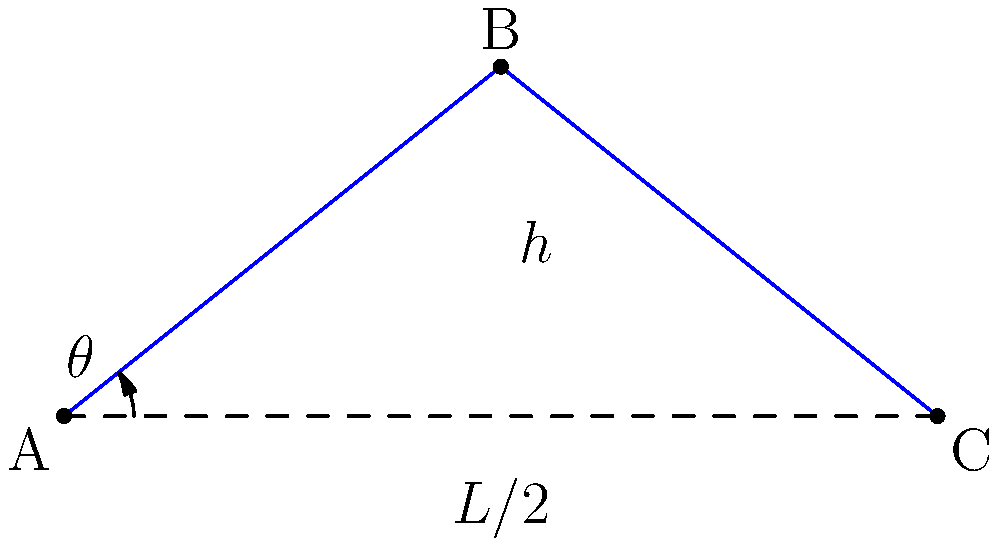In a study of spinal curvature, a medical researcher measures the following parameters:
- The length of the spine (L) is 50 cm
- The maximum height (h) of the curve from the base is 8 cm

Assuming the spine forms a symmetrical arc, calculate the angle $\theta$ (in degrees) between the base of the spine and the tangent line at the base. Round your answer to the nearest degree. To solve this problem, we can use trigonometric functions. Let's approach this step-by-step:

1) First, we need to recognize that we're dealing with a right triangle formed by half of the spine's length, the maximum height, and the radius of curvature.

2) We're given:
   - Total length (L) = 50 cm
   - Maximum height (h) = 8 cm

3) We need to use half of the total length: L/2 = 25 cm

4) Now we can use the inverse tangent function (arctan or $\tan^{-1}$) to find the angle $\theta$:

   $$\theta = \tan^{-1}\left(\frac{h}{L/2}\right)$$

5) Substituting our values:

   $$\theta = \tan^{-1}\left(\frac{8}{25}\right)$$

6) Using a calculator (or a computer):

   $$\theta \approx 17.74^\circ$$

7) Rounding to the nearest degree:

   $$\theta \approx 18^\circ$$

This angle represents the slope of the spine at its base, which is a useful measure of spinal curvature in medical research.
Answer: $18^\circ$ 